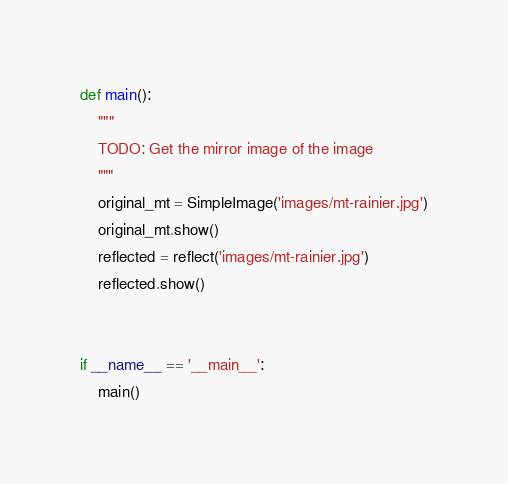<code> <loc_0><loc_0><loc_500><loc_500><_Python_>
def main():
    """
    TODO: Get the mirror image of the image
    """
    original_mt = SimpleImage('images/mt-rainier.jpg')
    original_mt.show()
    reflected = reflect('images/mt-rainier.jpg')
    reflected.show()


if __name__ == '__main__':
    main()
</code> 